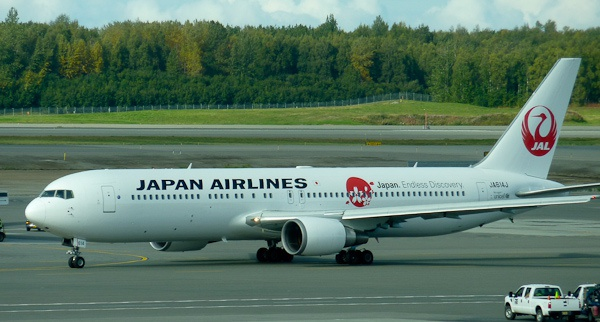Describe the objects in this image and their specific colors. I can see airplane in lightblue and black tones, truck in lightblue, black, and darkgray tones, truck in lightblue, black, gray, teal, and darkgray tones, and car in lightblue, black, teal, gray, and darkblue tones in this image. 